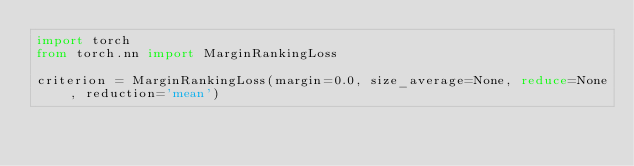<code> <loc_0><loc_0><loc_500><loc_500><_Python_>import torch
from torch.nn import MarginRankingLoss

criterion = MarginRankingLoss(margin=0.0, size_average=None, reduce=None, reduction='mean')

</code> 